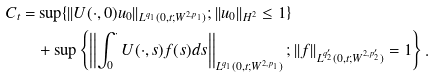Convert formula to latex. <formula><loc_0><loc_0><loc_500><loc_500>C _ { t } = & \sup \{ | | U ( \cdot , 0 ) u _ { 0 } | | _ { L ^ { q _ { 1 } } ( 0 , t ; W ^ { 2 , p _ { 1 } } ) } ; | | u _ { 0 } | | _ { H ^ { 2 } } \leq 1 \} \\ & + \sup \left \{ \left | \left | \int _ { 0 } ^ { \cdot } U ( \cdot , s ) f ( s ) d s \right | \right | _ { L ^ { q _ { 1 } } ( 0 , t ; W ^ { 2 , p _ { 1 } } ) } ; | | f | | _ { L ^ { q ^ { \prime } _ { 2 } } ( 0 , t ; W ^ { 2 , p ^ { \prime } _ { 2 } } ) } = 1 \right \} .</formula> 